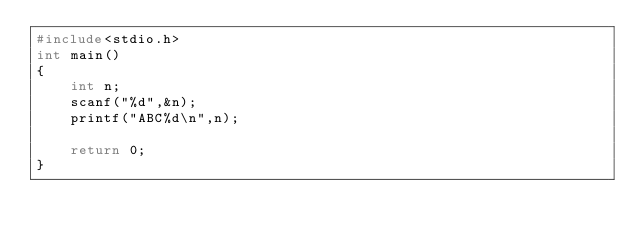Convert code to text. <code><loc_0><loc_0><loc_500><loc_500><_C_>#include<stdio.h>
int main()
{
    int n;
    scanf("%d",&n);
    printf("ABC%d\n",n);
    
    return 0;
}

</code> 